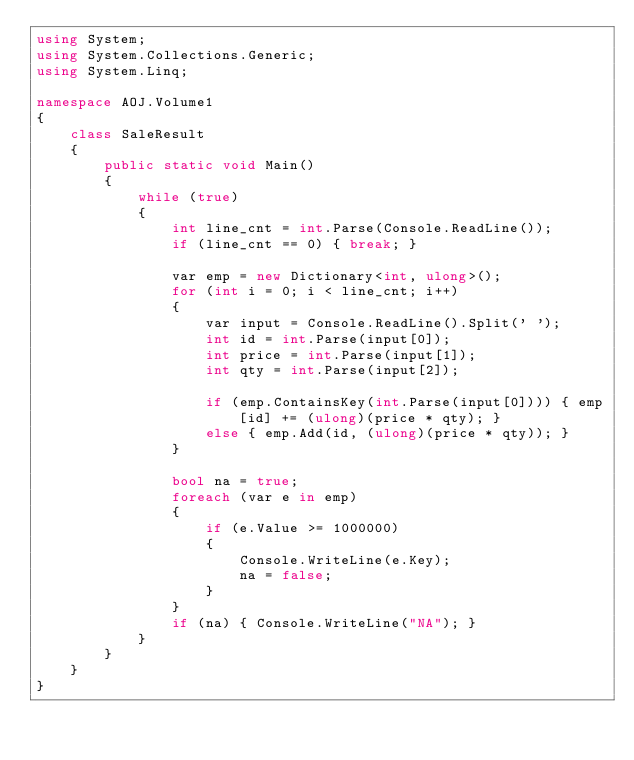<code> <loc_0><loc_0><loc_500><loc_500><_C#_>using System;
using System.Collections.Generic;
using System.Linq;

namespace AOJ.Volume1
{
    class SaleResult
    {
        public static void Main()
        {
            while (true)
            {
                int line_cnt = int.Parse(Console.ReadLine());
                if (line_cnt == 0) { break; }

                var emp = new Dictionary<int, ulong>();
                for (int i = 0; i < line_cnt; i++)
                {
                    var input = Console.ReadLine().Split(' ');
                    int id = int.Parse(input[0]);
                    int price = int.Parse(input[1]);
                    int qty = int.Parse(input[2]);

                    if (emp.ContainsKey(int.Parse(input[0]))) { emp[id] += (ulong)(price * qty); }
                    else { emp.Add(id, (ulong)(price * qty)); }
                }

                bool na = true;
                foreach (var e in emp)
                {
                    if (e.Value >= 1000000)
                    {
                        Console.WriteLine(e.Key);
                        na = false;
                    }
                }
                if (na) { Console.WriteLine("NA"); }
            }
        }
    }
}</code> 